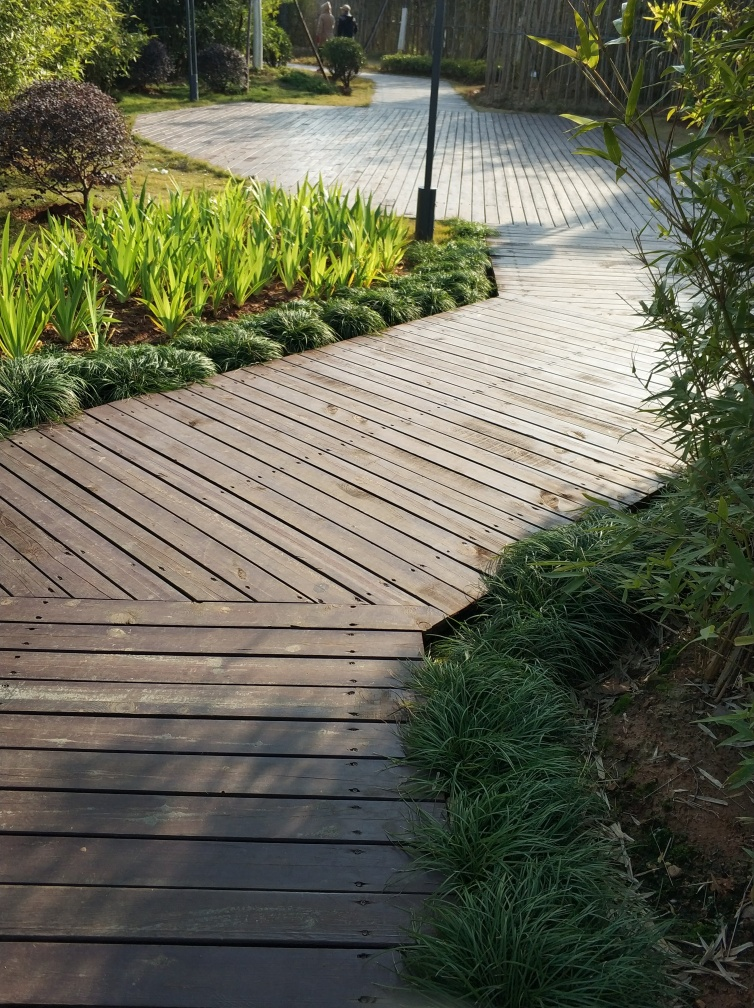Does the photo have good quality?
A. No
B. Yes
Answer with the option's letter from the given choices directly.
 B. 